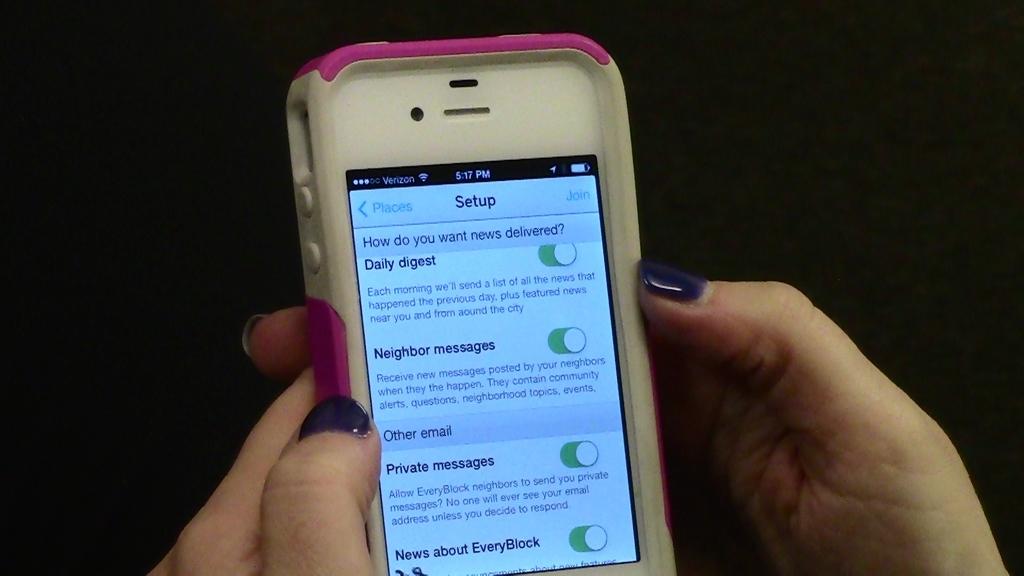What's the screen that they're on?
Your response must be concise. Setup. 